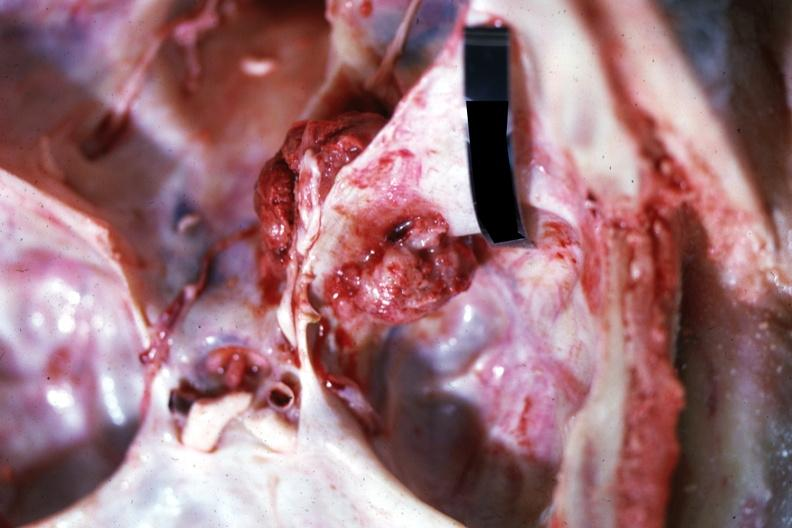what is present?
Answer the question using a single word or phrase. Bone 